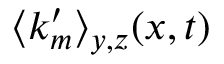<formula> <loc_0><loc_0><loc_500><loc_500>\langle k _ { m } ^ { \prime } \rangle _ { y , z } ( x , t )</formula> 